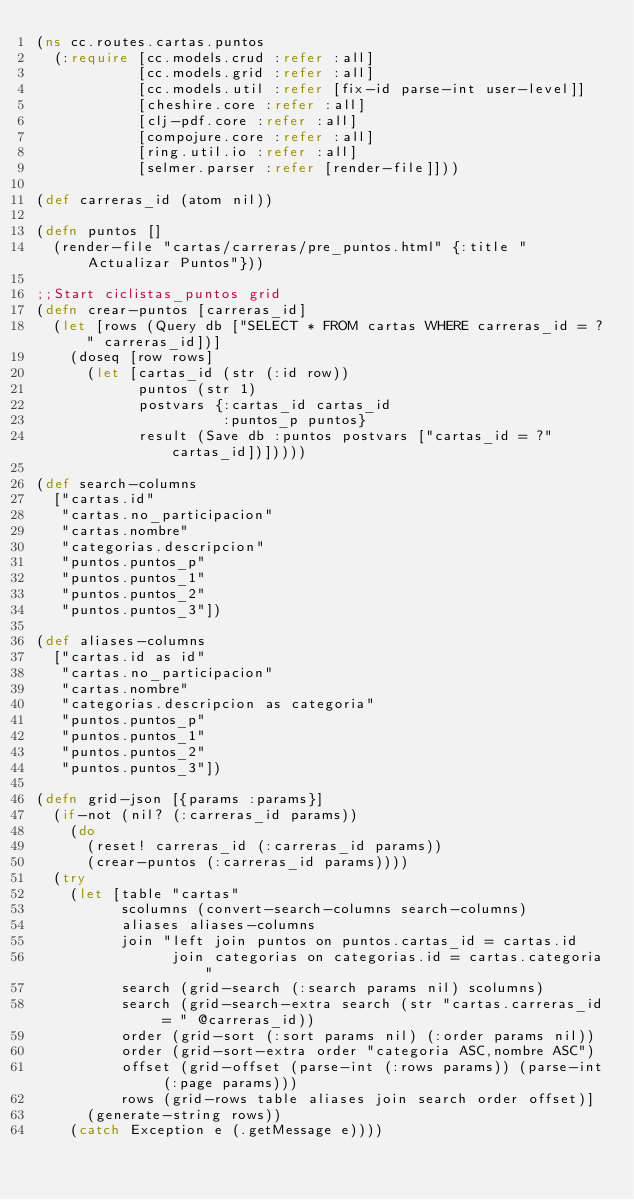<code> <loc_0><loc_0><loc_500><loc_500><_Clojure_>(ns cc.routes.cartas.puntos
  (:require [cc.models.crud :refer :all]
            [cc.models.grid :refer :all]
            [cc.models.util :refer [fix-id parse-int user-level]]
            [cheshire.core :refer :all]
            [clj-pdf.core :refer :all]
            [compojure.core :refer :all]
            [ring.util.io :refer :all]
            [selmer.parser :refer [render-file]]))

(def carreras_id (atom nil))

(defn puntos []
  (render-file "cartas/carreras/pre_puntos.html" {:title "Actualizar Puntos"}))

;;Start ciclistas_puntos grid
(defn crear-puntos [carreras_id]
  (let [rows (Query db ["SELECT * FROM cartas WHERE carreras_id = ?" carreras_id])]
    (doseq [row rows]
      (let [cartas_id (str (:id row))
            puntos (str 1)
            postvars {:cartas_id cartas_id
                      :puntos_p puntos}
            result (Save db :puntos postvars ["cartas_id = ?" cartas_id])]))))

(def search-columns
  ["cartas.id"
   "cartas.no_participacion"
   "cartas.nombre"
   "categorias.descripcion"
   "puntos.puntos_p"
   "puntos.puntos_1"
   "puntos.puntos_2"
   "puntos.puntos_3"])

(def aliases-columns
  ["cartas.id as id"
   "cartas.no_participacion"
   "cartas.nombre"
   "categorias.descripcion as categoria"
   "puntos.puntos_p"
   "puntos.puntos_1"
   "puntos.puntos_2"
   "puntos.puntos_3"])

(defn grid-json [{params :params}]
  (if-not (nil? (:carreras_id params))
    (do
      (reset! carreras_id (:carreras_id params))
      (crear-puntos (:carreras_id params))))
  (try
    (let [table "cartas"
          scolumns (convert-search-columns search-columns)
          aliases aliases-columns
          join "left join puntos on puntos.cartas_id = cartas.id
                join categorias on categorias.id = cartas.categoria"
          search (grid-search (:search params nil) scolumns)
          search (grid-search-extra search (str "cartas.carreras_id = " @carreras_id))
          order (grid-sort (:sort params nil) (:order params nil))
          order (grid-sort-extra order "categoria ASC,nombre ASC")
          offset (grid-offset (parse-int (:rows params)) (parse-int (:page params)))
          rows (grid-rows table aliases join search order offset)]
      (generate-string rows))
    (catch Exception e (.getMessage e))))</code> 